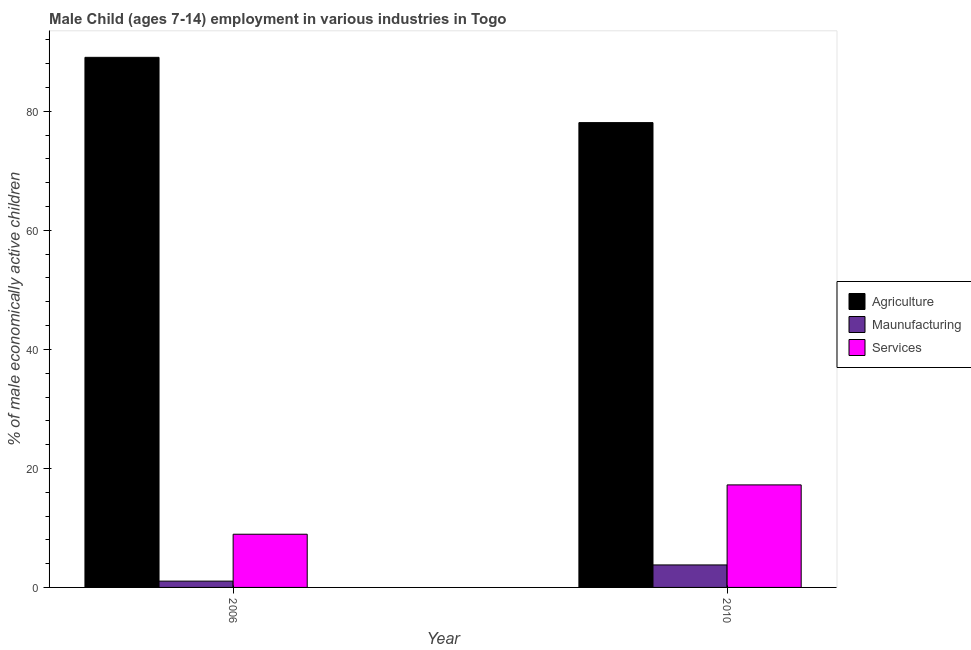How many different coloured bars are there?
Offer a terse response. 3. How many groups of bars are there?
Keep it short and to the point. 2. Are the number of bars on each tick of the X-axis equal?
Your answer should be compact. Yes. How many bars are there on the 2nd tick from the left?
Your answer should be compact. 3. How many bars are there on the 2nd tick from the right?
Offer a very short reply. 3. What is the label of the 2nd group of bars from the left?
Make the answer very short. 2010. In how many cases, is the number of bars for a given year not equal to the number of legend labels?
Your answer should be very brief. 0. What is the percentage of economically active children in agriculture in 2010?
Ensure brevity in your answer.  78.11. Across all years, what is the maximum percentage of economically active children in agriculture?
Make the answer very short. 89.08. Across all years, what is the minimum percentage of economically active children in agriculture?
Give a very brief answer. 78.11. In which year was the percentage of economically active children in manufacturing maximum?
Offer a very short reply. 2010. In which year was the percentage of economically active children in agriculture minimum?
Provide a short and direct response. 2010. What is the total percentage of economically active children in manufacturing in the graph?
Your answer should be very brief. 4.84. What is the difference between the percentage of economically active children in agriculture in 2006 and that in 2010?
Your answer should be very brief. 10.97. What is the difference between the percentage of economically active children in agriculture in 2010 and the percentage of economically active children in services in 2006?
Offer a terse response. -10.97. What is the average percentage of economically active children in manufacturing per year?
Make the answer very short. 2.42. In how many years, is the percentage of economically active children in services greater than 44 %?
Offer a very short reply. 0. What is the ratio of the percentage of economically active children in services in 2006 to that in 2010?
Your answer should be very brief. 0.52. Is the percentage of economically active children in manufacturing in 2006 less than that in 2010?
Your response must be concise. Yes. In how many years, is the percentage of economically active children in services greater than the average percentage of economically active children in services taken over all years?
Offer a terse response. 1. What does the 3rd bar from the left in 2006 represents?
Your answer should be very brief. Services. What does the 2nd bar from the right in 2006 represents?
Keep it short and to the point. Maunufacturing. Is it the case that in every year, the sum of the percentage of economically active children in agriculture and percentage of economically active children in manufacturing is greater than the percentage of economically active children in services?
Offer a terse response. Yes. Are all the bars in the graph horizontal?
Your answer should be compact. No. How many years are there in the graph?
Ensure brevity in your answer.  2. What is the difference between two consecutive major ticks on the Y-axis?
Offer a very short reply. 20. Are the values on the major ticks of Y-axis written in scientific E-notation?
Offer a very short reply. No. Where does the legend appear in the graph?
Give a very brief answer. Center right. What is the title of the graph?
Your answer should be compact. Male Child (ages 7-14) employment in various industries in Togo. What is the label or title of the Y-axis?
Your answer should be compact. % of male economically active children. What is the % of male economically active children in Agriculture in 2006?
Offer a terse response. 89.08. What is the % of male economically active children of Maunufacturing in 2006?
Offer a terse response. 1.06. What is the % of male economically active children of Services in 2006?
Your response must be concise. 8.94. What is the % of male economically active children of Agriculture in 2010?
Ensure brevity in your answer.  78.11. What is the % of male economically active children in Maunufacturing in 2010?
Your response must be concise. 3.78. What is the % of male economically active children in Services in 2010?
Provide a short and direct response. 17.23. Across all years, what is the maximum % of male economically active children of Agriculture?
Provide a succinct answer. 89.08. Across all years, what is the maximum % of male economically active children of Maunufacturing?
Ensure brevity in your answer.  3.78. Across all years, what is the maximum % of male economically active children of Services?
Provide a succinct answer. 17.23. Across all years, what is the minimum % of male economically active children of Agriculture?
Provide a short and direct response. 78.11. Across all years, what is the minimum % of male economically active children in Maunufacturing?
Ensure brevity in your answer.  1.06. Across all years, what is the minimum % of male economically active children of Services?
Keep it short and to the point. 8.94. What is the total % of male economically active children in Agriculture in the graph?
Offer a terse response. 167.19. What is the total % of male economically active children in Maunufacturing in the graph?
Your answer should be compact. 4.84. What is the total % of male economically active children of Services in the graph?
Offer a terse response. 26.17. What is the difference between the % of male economically active children in Agriculture in 2006 and that in 2010?
Keep it short and to the point. 10.97. What is the difference between the % of male economically active children in Maunufacturing in 2006 and that in 2010?
Your response must be concise. -2.72. What is the difference between the % of male economically active children in Services in 2006 and that in 2010?
Ensure brevity in your answer.  -8.29. What is the difference between the % of male economically active children of Agriculture in 2006 and the % of male economically active children of Maunufacturing in 2010?
Your answer should be compact. 85.3. What is the difference between the % of male economically active children in Agriculture in 2006 and the % of male economically active children in Services in 2010?
Provide a succinct answer. 71.85. What is the difference between the % of male economically active children in Maunufacturing in 2006 and the % of male economically active children in Services in 2010?
Ensure brevity in your answer.  -16.17. What is the average % of male economically active children in Agriculture per year?
Keep it short and to the point. 83.59. What is the average % of male economically active children of Maunufacturing per year?
Your answer should be very brief. 2.42. What is the average % of male economically active children in Services per year?
Provide a short and direct response. 13.09. In the year 2006, what is the difference between the % of male economically active children of Agriculture and % of male economically active children of Maunufacturing?
Make the answer very short. 88.02. In the year 2006, what is the difference between the % of male economically active children in Agriculture and % of male economically active children in Services?
Your answer should be compact. 80.14. In the year 2006, what is the difference between the % of male economically active children of Maunufacturing and % of male economically active children of Services?
Your response must be concise. -7.88. In the year 2010, what is the difference between the % of male economically active children in Agriculture and % of male economically active children in Maunufacturing?
Provide a short and direct response. 74.33. In the year 2010, what is the difference between the % of male economically active children of Agriculture and % of male economically active children of Services?
Keep it short and to the point. 60.88. In the year 2010, what is the difference between the % of male economically active children in Maunufacturing and % of male economically active children in Services?
Offer a terse response. -13.45. What is the ratio of the % of male economically active children of Agriculture in 2006 to that in 2010?
Offer a very short reply. 1.14. What is the ratio of the % of male economically active children of Maunufacturing in 2006 to that in 2010?
Your response must be concise. 0.28. What is the ratio of the % of male economically active children of Services in 2006 to that in 2010?
Your answer should be compact. 0.52. What is the difference between the highest and the second highest % of male economically active children in Agriculture?
Ensure brevity in your answer.  10.97. What is the difference between the highest and the second highest % of male economically active children of Maunufacturing?
Make the answer very short. 2.72. What is the difference between the highest and the second highest % of male economically active children in Services?
Give a very brief answer. 8.29. What is the difference between the highest and the lowest % of male economically active children in Agriculture?
Give a very brief answer. 10.97. What is the difference between the highest and the lowest % of male economically active children of Maunufacturing?
Offer a very short reply. 2.72. What is the difference between the highest and the lowest % of male economically active children of Services?
Offer a very short reply. 8.29. 